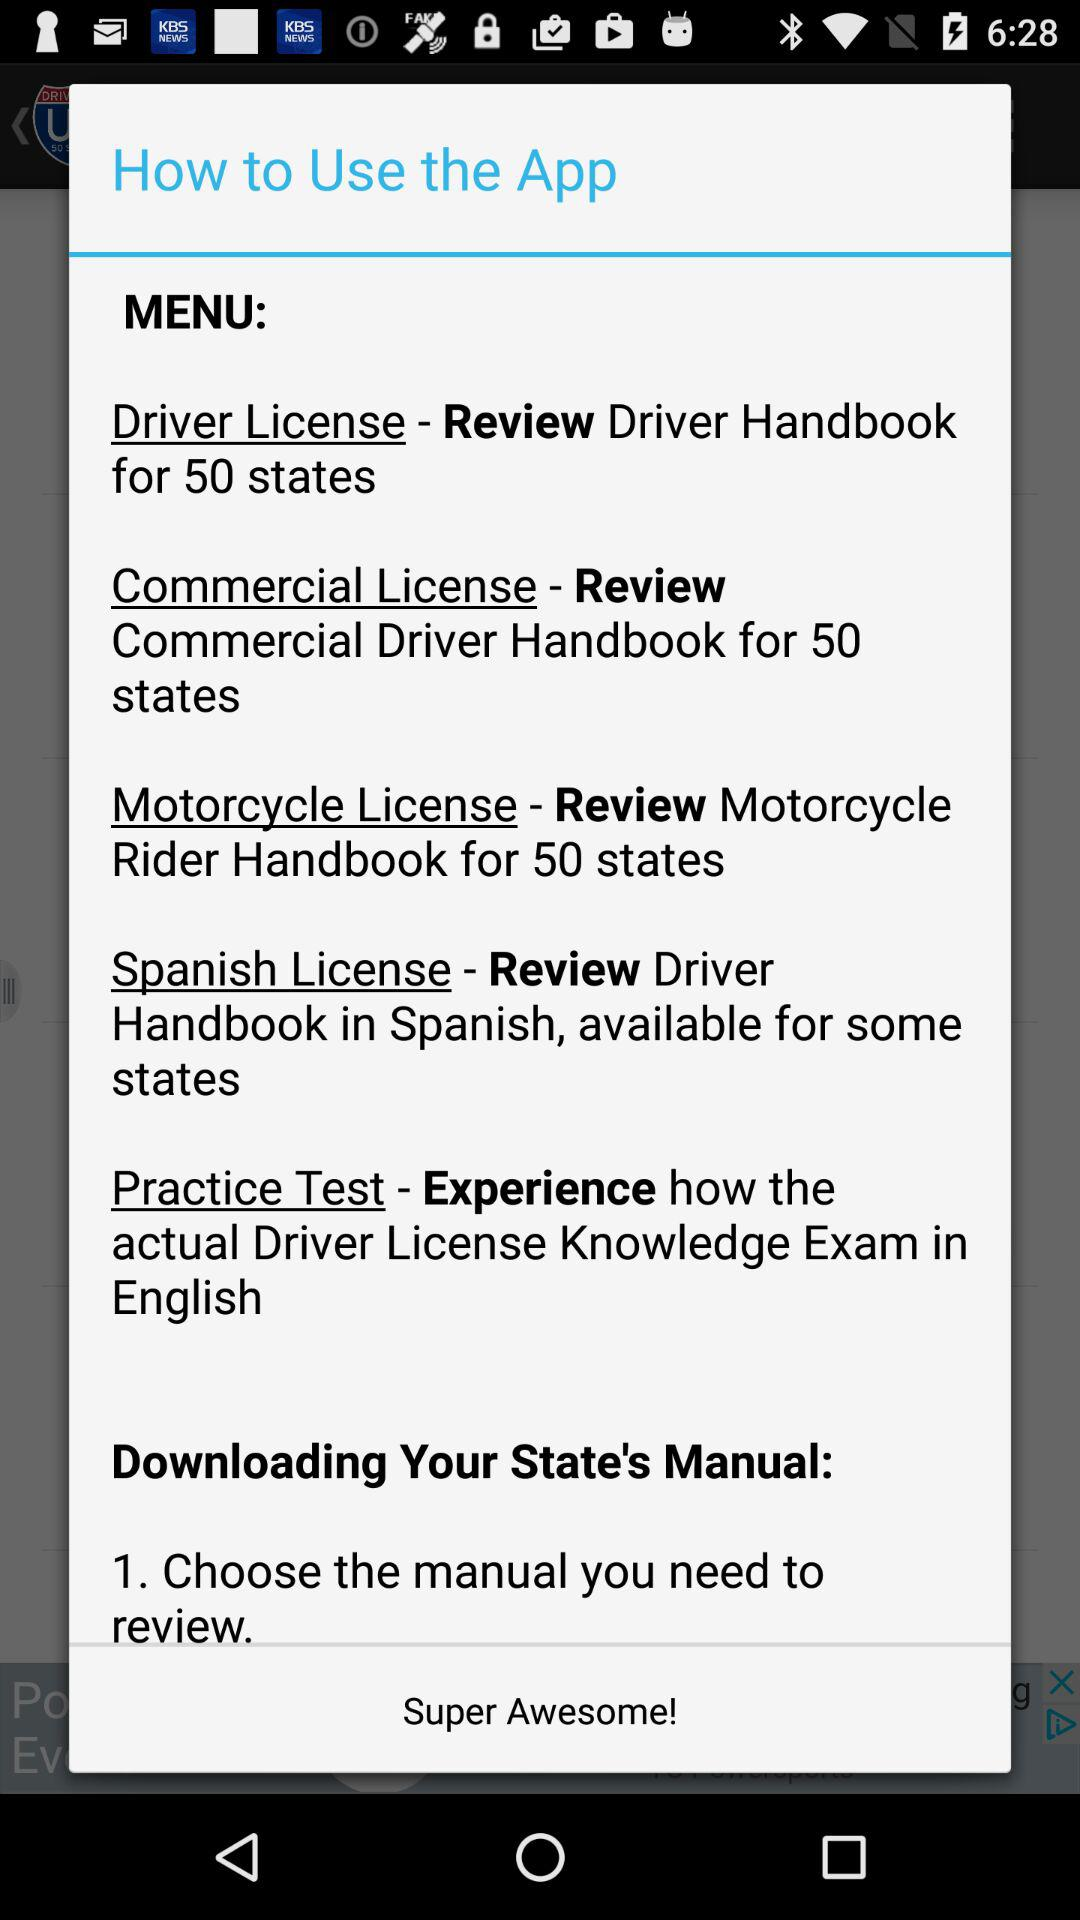What are the names of the different available licenses? The names of the different available licenses are "Driver License", "Commercial License", "Motorcycle License" and "Spanish License". 